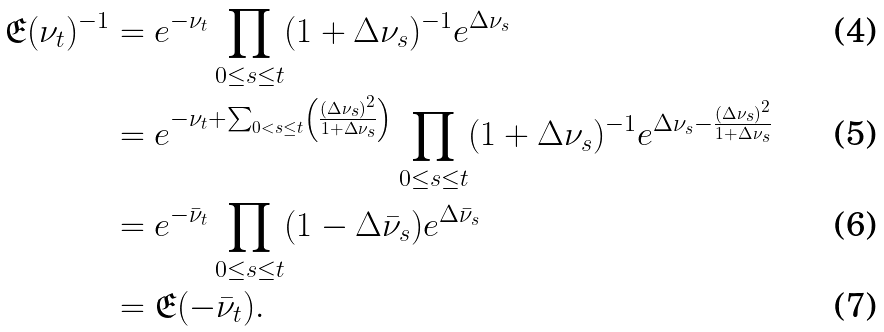Convert formula to latex. <formula><loc_0><loc_0><loc_500><loc_500>\mathfrak { E } ( \nu _ { t } ) ^ { - 1 } & = e ^ { - \nu _ { t } } \prod _ { 0 \leq s \leq t } ( 1 + \Delta \nu _ { s } ) ^ { - 1 } e ^ { \Delta \nu _ { s } } \\ & = e ^ { - \nu _ { t } + \sum _ { 0 < s \leq t } \left ( \frac { ( \Delta \nu _ { s } ) ^ { 2 } } { 1 + \Delta \nu _ { s } } \right ) } \prod _ { 0 \leq s \leq t } ( 1 + \Delta \nu _ { s } ) ^ { - 1 } e ^ { \Delta \nu _ { s } - \frac { ( \Delta \nu _ { s } ) ^ { 2 } } { 1 + \Delta \nu _ { s } } } \\ & = e ^ { - \bar { \nu } _ { t } } \prod _ { 0 \leq s \leq t } ( 1 - \Delta \bar { \nu } _ { s } ) e ^ { \Delta \bar { \nu } _ { s } } \\ & = \mathfrak { E } ( - \bar { \nu } _ { t } ) .</formula> 